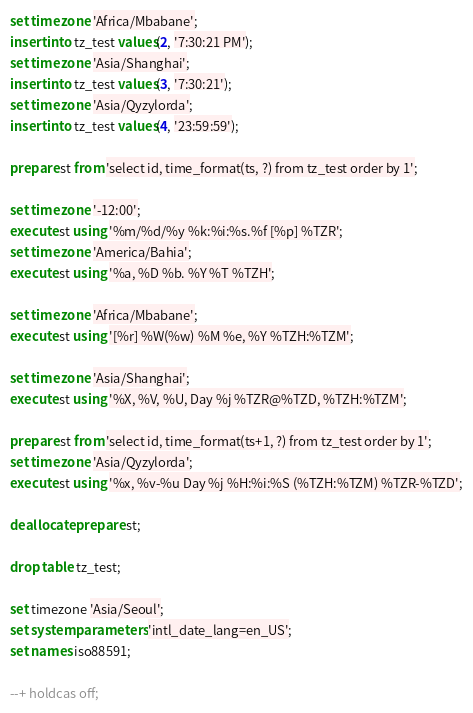Convert code to text. <code><loc_0><loc_0><loc_500><loc_500><_SQL_>set time zone 'Africa/Mbabane';
insert into tz_test values(2, '7:30:21 PM');
set time zone 'Asia/Shanghai';
insert into tz_test values(3, '7:30:21');
set time zone 'Asia/Qyzylorda';
insert into tz_test values(4, '23:59:59');

prepare st from 'select id, time_format(ts, ?) from tz_test order by 1';

set time zone '-12:00';
execute st using '%m/%d/%y %k:%i:%s.%f [%p] %TZR';
set time zone 'America/Bahia';
execute st using '%a, %D %b. %Y %T %TZH';

set time zone 'Africa/Mbabane';
execute st using '[%r] %W(%w) %M %e, %Y %TZH:%TZM';

set time zone 'Asia/Shanghai';
execute st using '%X, %V, %U, Day %j %TZR@%TZD, %TZH:%TZM';

prepare st from 'select id, time_format(ts+1, ?) from tz_test order by 1';
set time zone 'Asia/Qyzylorda';
execute st using '%x, %v-%u Day %j %H:%i:%S (%TZH:%TZM) %TZR-%TZD';

deallocate prepare st;

drop table tz_test;

set timezone 'Asia/Seoul';
set system parameters 'intl_date_lang=en_US';
set names iso88591;

--+ holdcas off;
</code> 